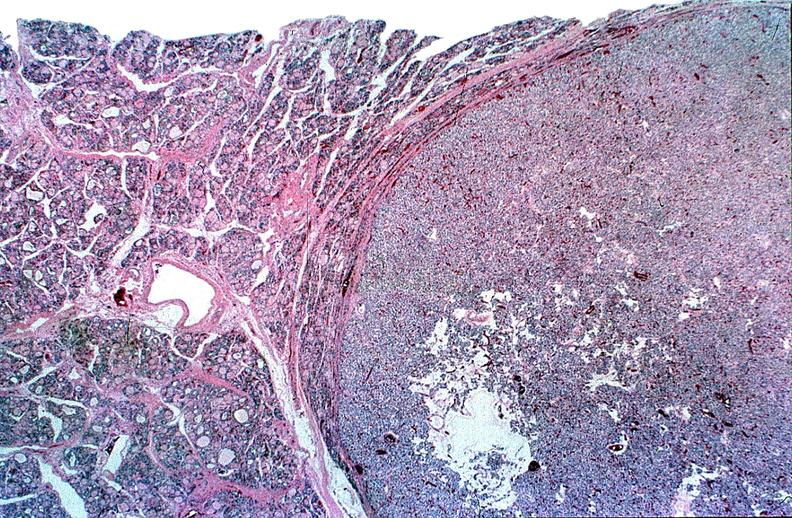what is present?
Answer the question using a single word or phrase. Endocrine 